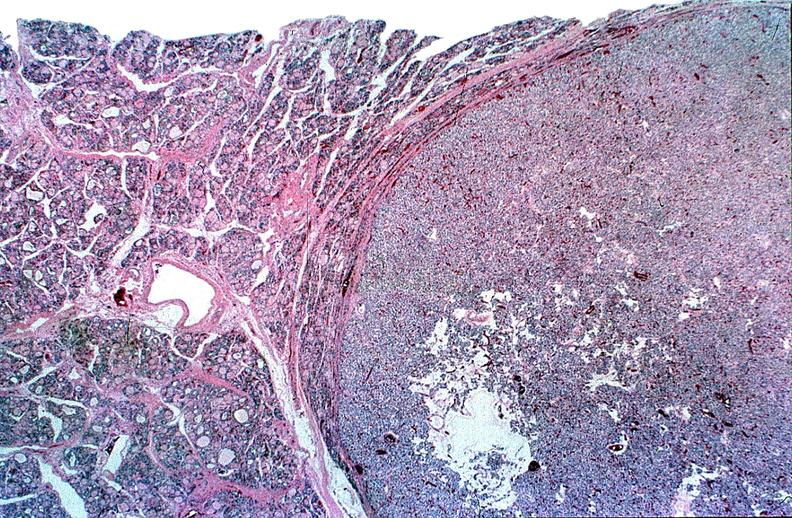what is present?
Answer the question using a single word or phrase. Endocrine 